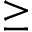Convert formula to latex. <formula><loc_0><loc_0><loc_500><loc_500>\geq</formula> 